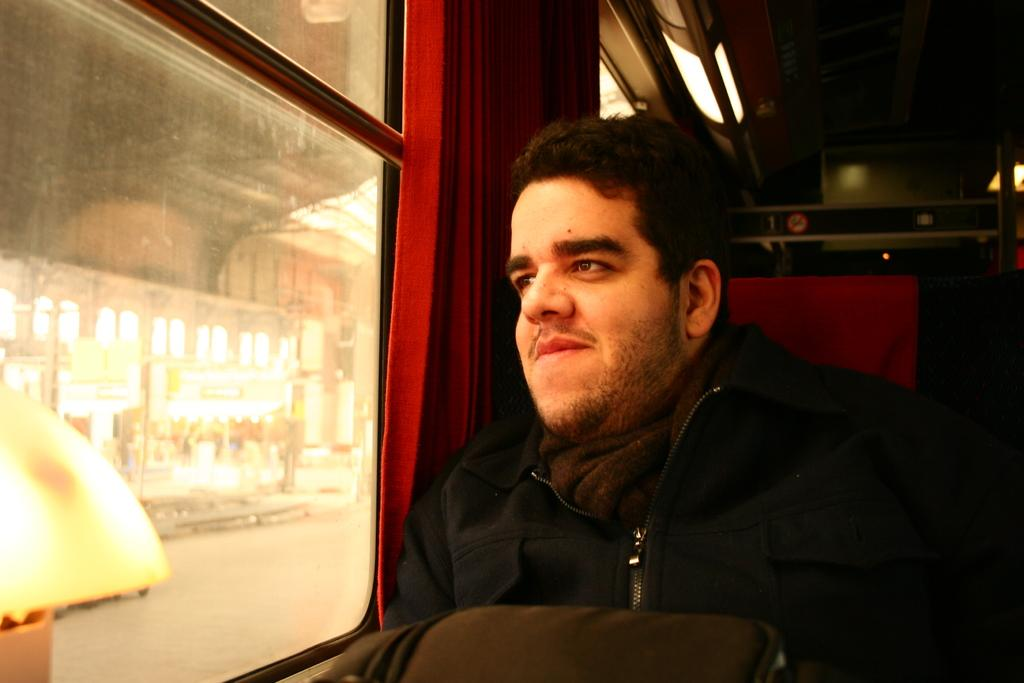What is happening in the foreground of the image? There is a person sitting in the foreground of the image. What is the person doing in the image? The person is looking at someone. What can be seen on the left side of the image? There is a window on the left side of the image. What color is the paint on the chicken in the image? There is no chicken or paint present in the image. How many jellyfish can be seen swimming in the window? There are no jellyfish visible in the window; it is a regular window with no aquatic life present. 